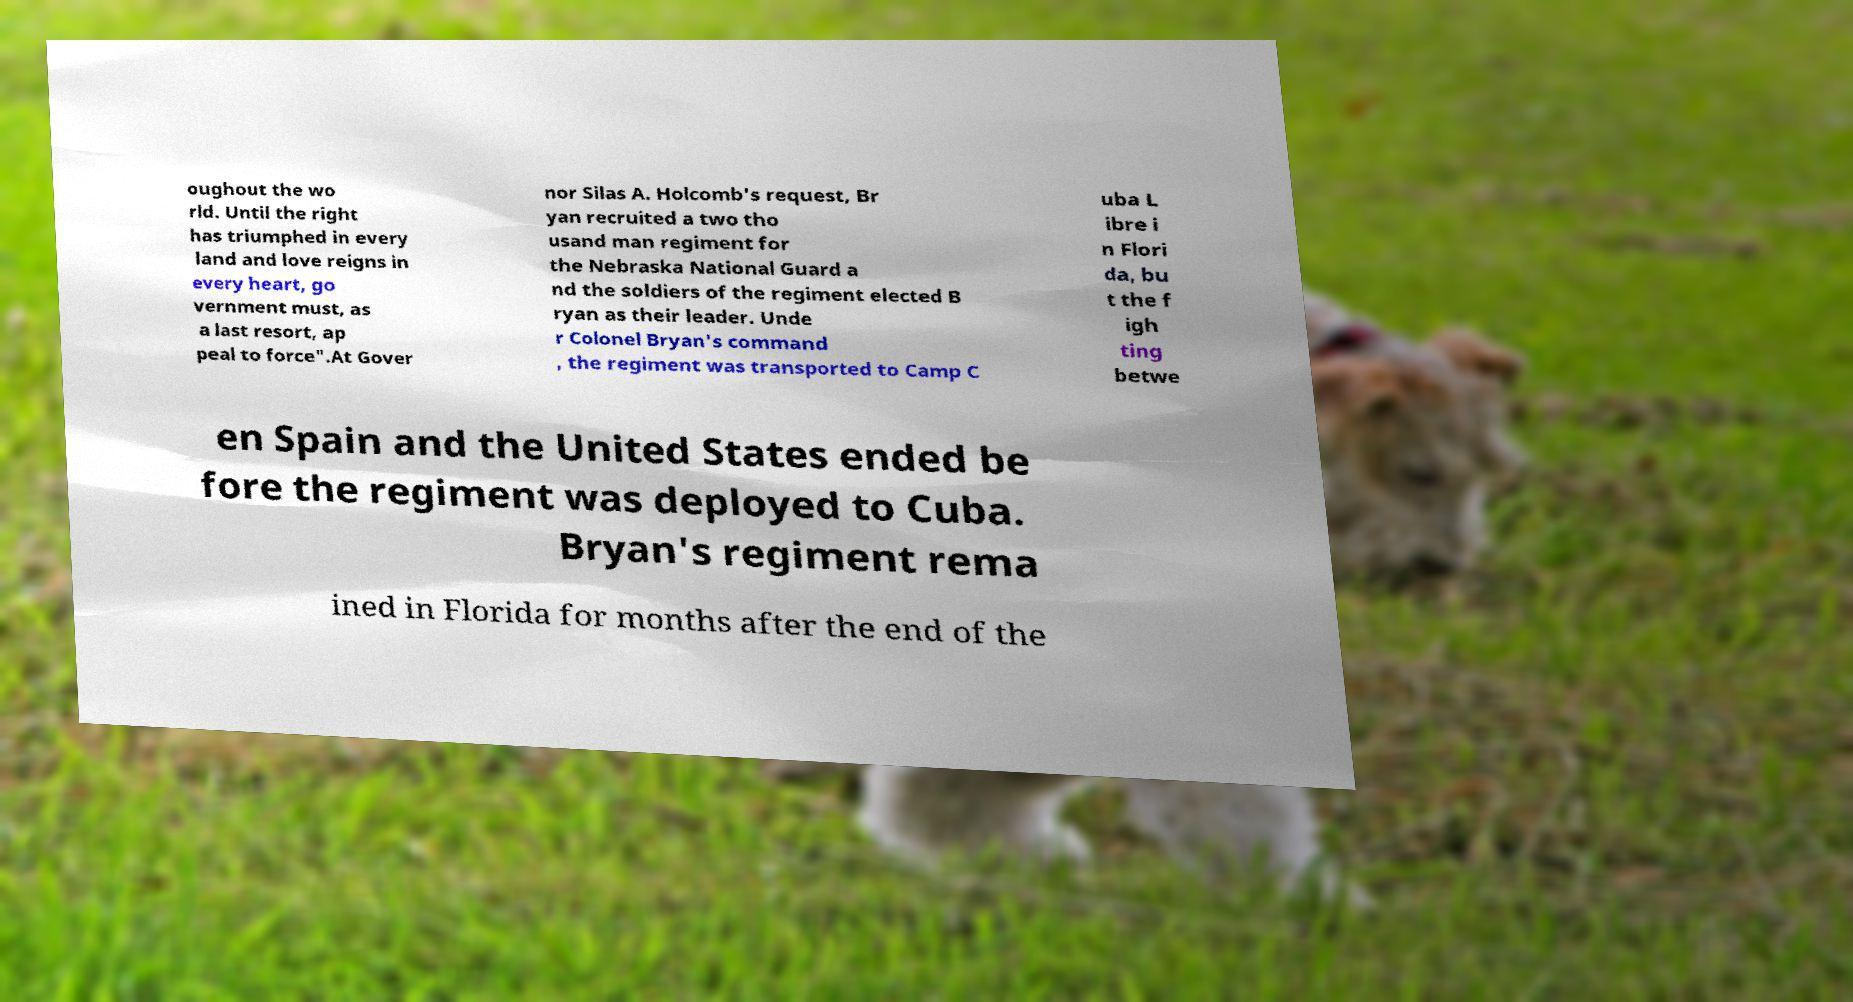Can you read and provide the text displayed in the image?This photo seems to have some interesting text. Can you extract and type it out for me? oughout the wo rld. Until the right has triumphed in every land and love reigns in every heart, go vernment must, as a last resort, ap peal to force".At Gover nor Silas A. Holcomb's request, Br yan recruited a two tho usand man regiment for the Nebraska National Guard a nd the soldiers of the regiment elected B ryan as their leader. Unde r Colonel Bryan's command , the regiment was transported to Camp C uba L ibre i n Flori da, bu t the f igh ting betwe en Spain and the United States ended be fore the regiment was deployed to Cuba. Bryan's regiment rema ined in Florida for months after the end of the 